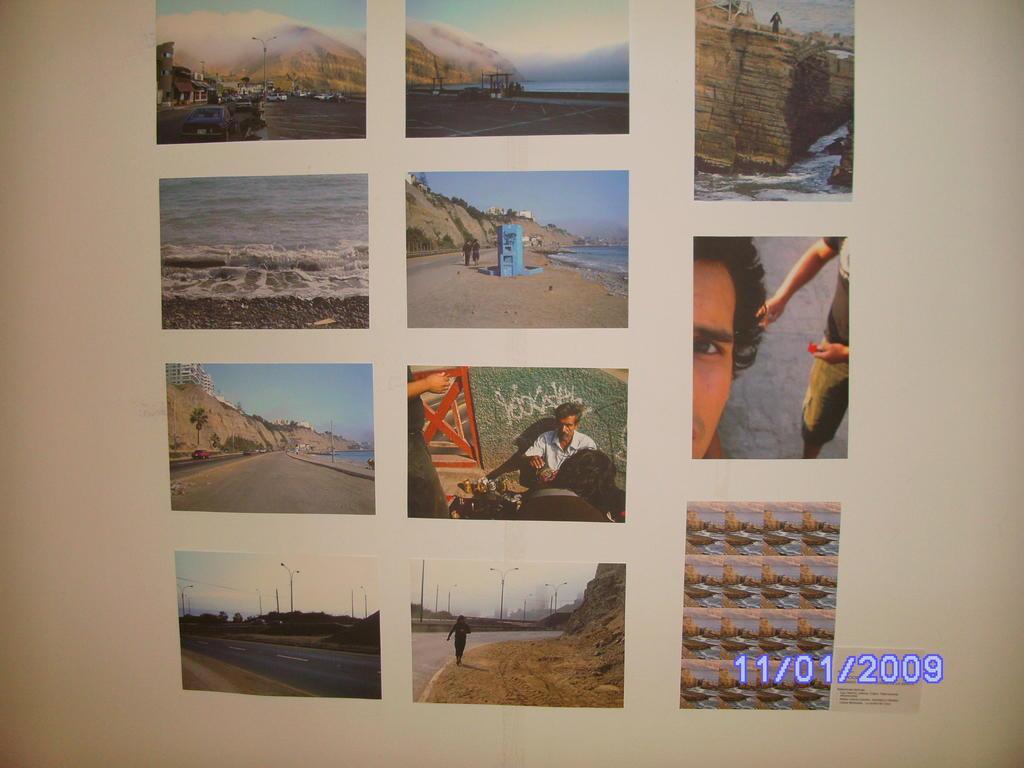Please provide a concise description of this image. In this image, I can see the pictures on the white surface. At the bottom of the image, I can see the watermark. There are few people, mountains, roads in these pictures. 